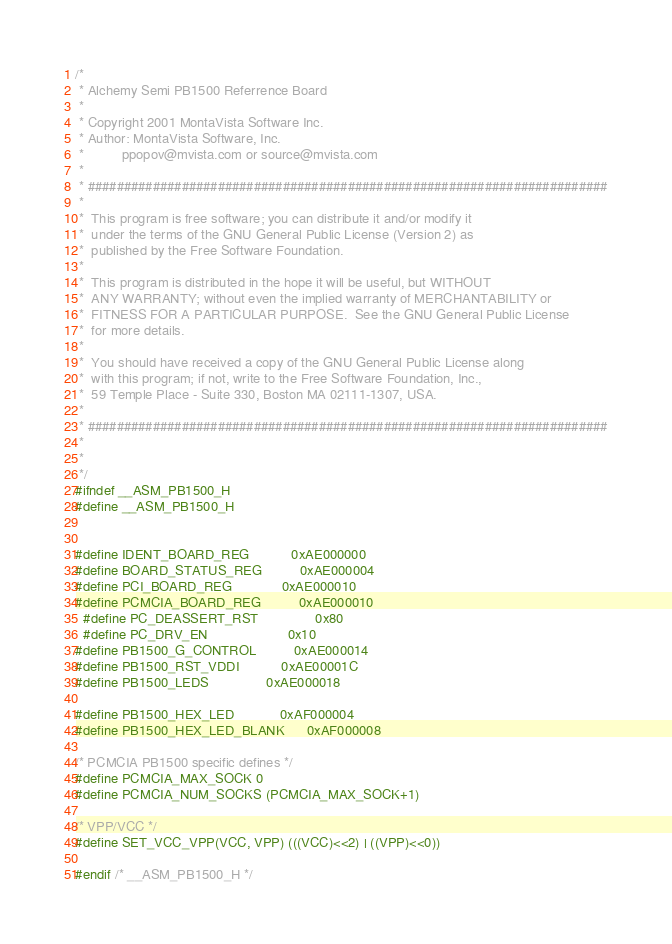<code> <loc_0><loc_0><loc_500><loc_500><_C_>/*
 * Alchemy Semi PB1500 Referrence Board
 *
 * Copyright 2001 MontaVista Software Inc.
 * Author: MontaVista Software, Inc.
 *         	ppopov@mvista.com or source@mvista.com
 *
 * ########################################################################
 *
 *  This program is free software; you can distribute it and/or modify it
 *  under the terms of the GNU General Public License (Version 2) as
 *  published by the Free Software Foundation.
 *
 *  This program is distributed in the hope it will be useful, but WITHOUT
 *  ANY WARRANTY; without even the implied warranty of MERCHANTABILITY or
 *  FITNESS FOR A PARTICULAR PURPOSE.  See the GNU General Public License
 *  for more details.
 *
 *  You should have received a copy of the GNU General Public License along
 *  with this program; if not, write to the Free Software Foundation, Inc.,
 *  59 Temple Place - Suite 330, Boston MA 02111-1307, USA.
 *
 * ########################################################################
 *
 *
 */
#ifndef __ASM_PB1500_H
#define __ASM_PB1500_H


#define IDENT_BOARD_REG           0xAE000000
#define BOARD_STATUS_REG          0xAE000004
#define PCI_BOARD_REG             0xAE000010
#define PCMCIA_BOARD_REG          0xAE000010
  #define PC_DEASSERT_RST               0x80
  #define PC_DRV_EN                     0x10
#define PB1500_G_CONTROL          0xAE000014
#define PB1500_RST_VDDI           0xAE00001C
#define PB1500_LEDS               0xAE000018

#define PB1500_HEX_LED            0xAF000004
#define PB1500_HEX_LED_BLANK      0xAF000008

/* PCMCIA PB1500 specific defines */
#define PCMCIA_MAX_SOCK 0
#define PCMCIA_NUM_SOCKS (PCMCIA_MAX_SOCK+1)

/* VPP/VCC */
#define SET_VCC_VPP(VCC, VPP) (((VCC)<<2) | ((VPP)<<0))

#endif /* __ASM_PB1500_H */
</code> 